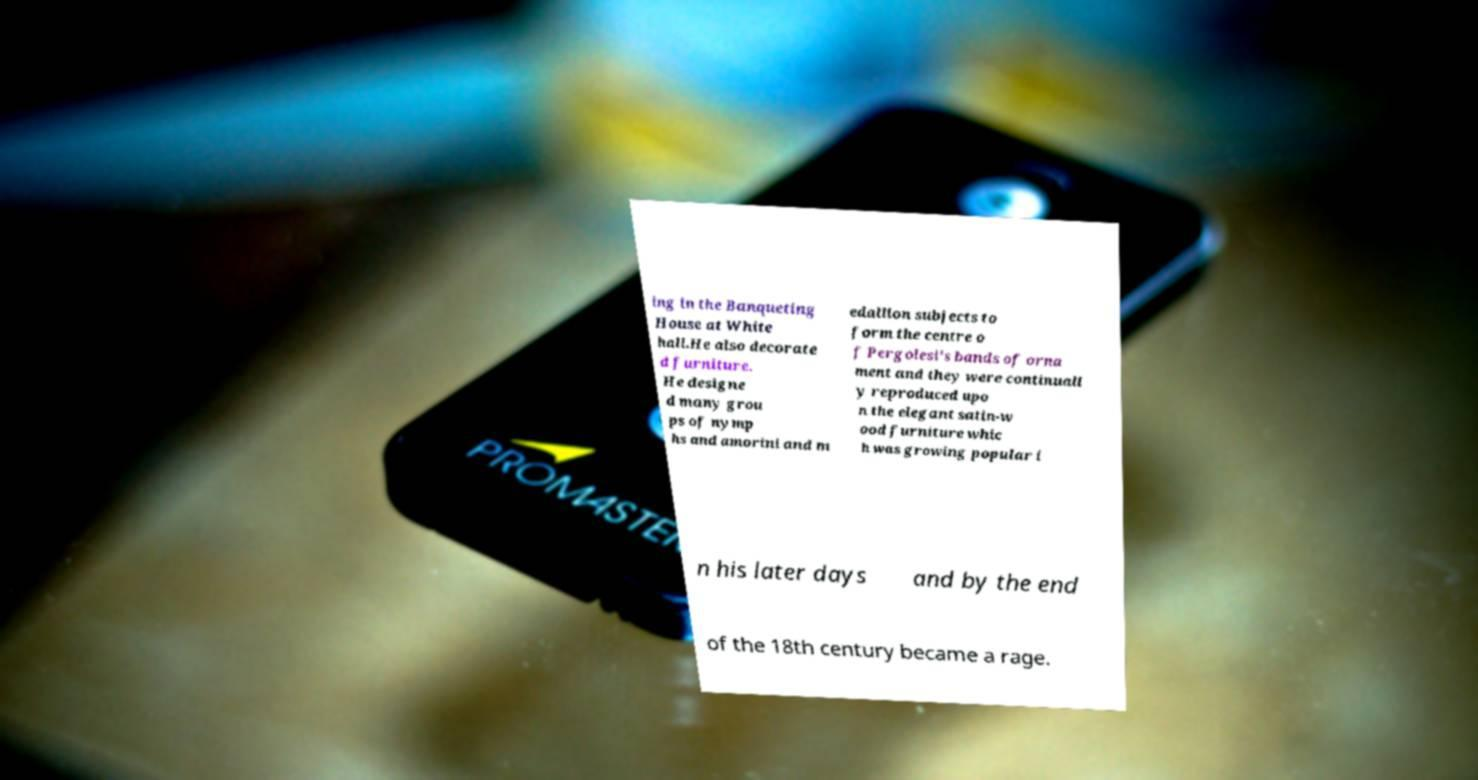What messages or text are displayed in this image? I need them in a readable, typed format. ing in the Banqueting House at White hall.He also decorate d furniture. He designe d many grou ps of nymp hs and amorini and m edallion subjects to form the centre o f Pergolesi's bands of orna ment and they were continuall y reproduced upo n the elegant satin-w ood furniture whic h was growing popular i n his later days and by the end of the 18th century became a rage. 